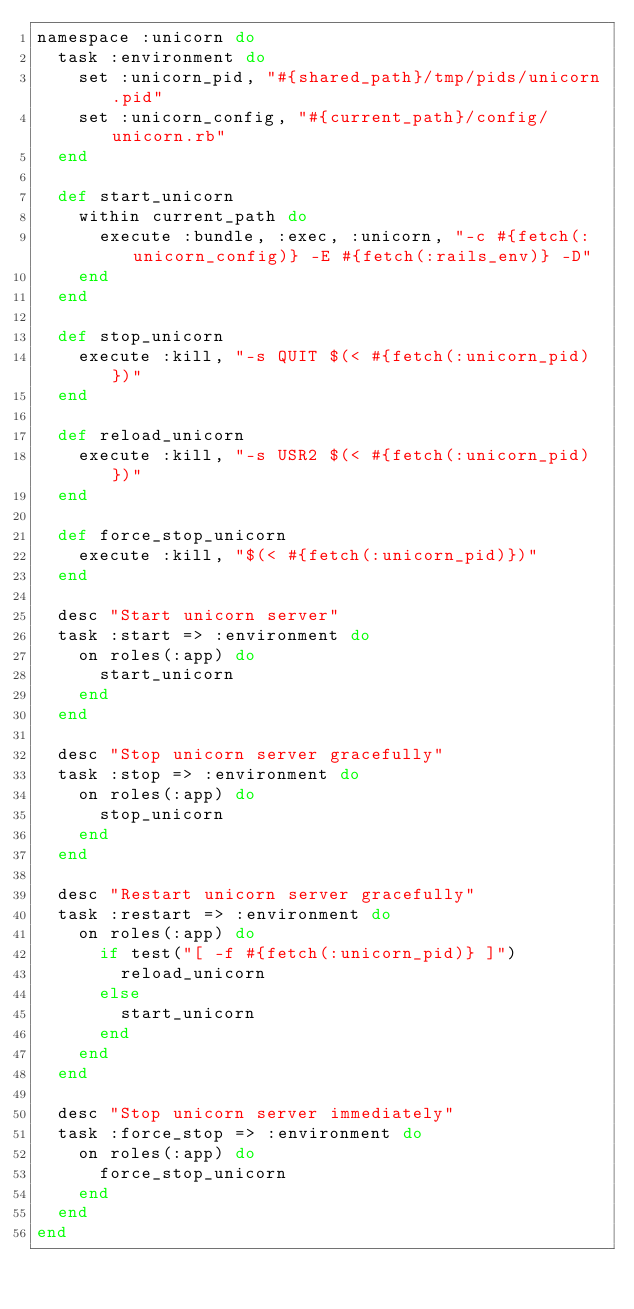Convert code to text. <code><loc_0><loc_0><loc_500><loc_500><_Ruby_>namespace :unicorn do
  task :environment do
    set :unicorn_pid, "#{shared_path}/tmp/pids/unicorn.pid"
    set :unicorn_config, "#{current_path}/config/unicorn.rb"
  end

  def start_unicorn
    within current_path do
      execute :bundle, :exec, :unicorn, "-c #{fetch(:unicorn_config)} -E #{fetch(:rails_env)} -D"
    end
  end

  def stop_unicorn
    execute :kill, "-s QUIT $(< #{fetch(:unicorn_pid)})"
  end

  def reload_unicorn
    execute :kill, "-s USR2 $(< #{fetch(:unicorn_pid)})"
  end

  def force_stop_unicorn
    execute :kill, "$(< #{fetch(:unicorn_pid)})"
  end

  desc "Start unicorn server"
  task :start => :environment do
    on roles(:app) do
      start_unicorn
    end
  end

  desc "Stop unicorn server gracefully"
  task :stop => :environment do
    on roles(:app) do
      stop_unicorn
    end
  end

  desc "Restart unicorn server gracefully"
  task :restart => :environment do
    on roles(:app) do
      if test("[ -f #{fetch(:unicorn_pid)} ]")
        reload_unicorn
      else
        start_unicorn
      end
    end
  end

  desc "Stop unicorn server immediately"
  task :force_stop => :environment do
    on roles(:app) do
      force_stop_unicorn
    end
  end
end
</code> 